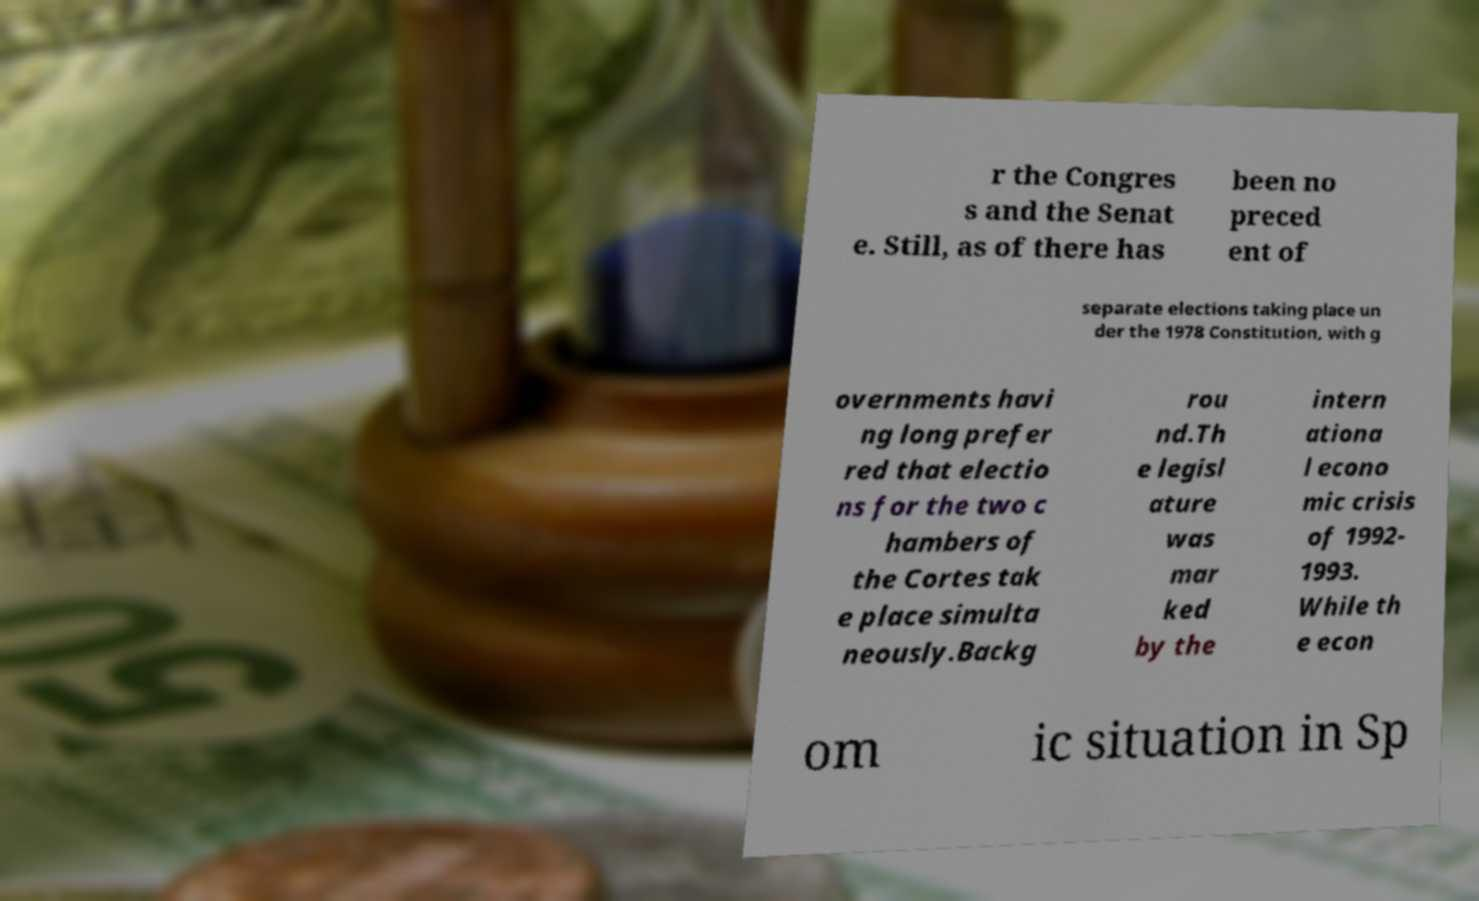There's text embedded in this image that I need extracted. Can you transcribe it verbatim? r the Congres s and the Senat e. Still, as of there has been no preced ent of separate elections taking place un der the 1978 Constitution, with g overnments havi ng long prefer red that electio ns for the two c hambers of the Cortes tak e place simulta neously.Backg rou nd.Th e legisl ature was mar ked by the intern ationa l econo mic crisis of 1992- 1993. While th e econ om ic situation in Sp 